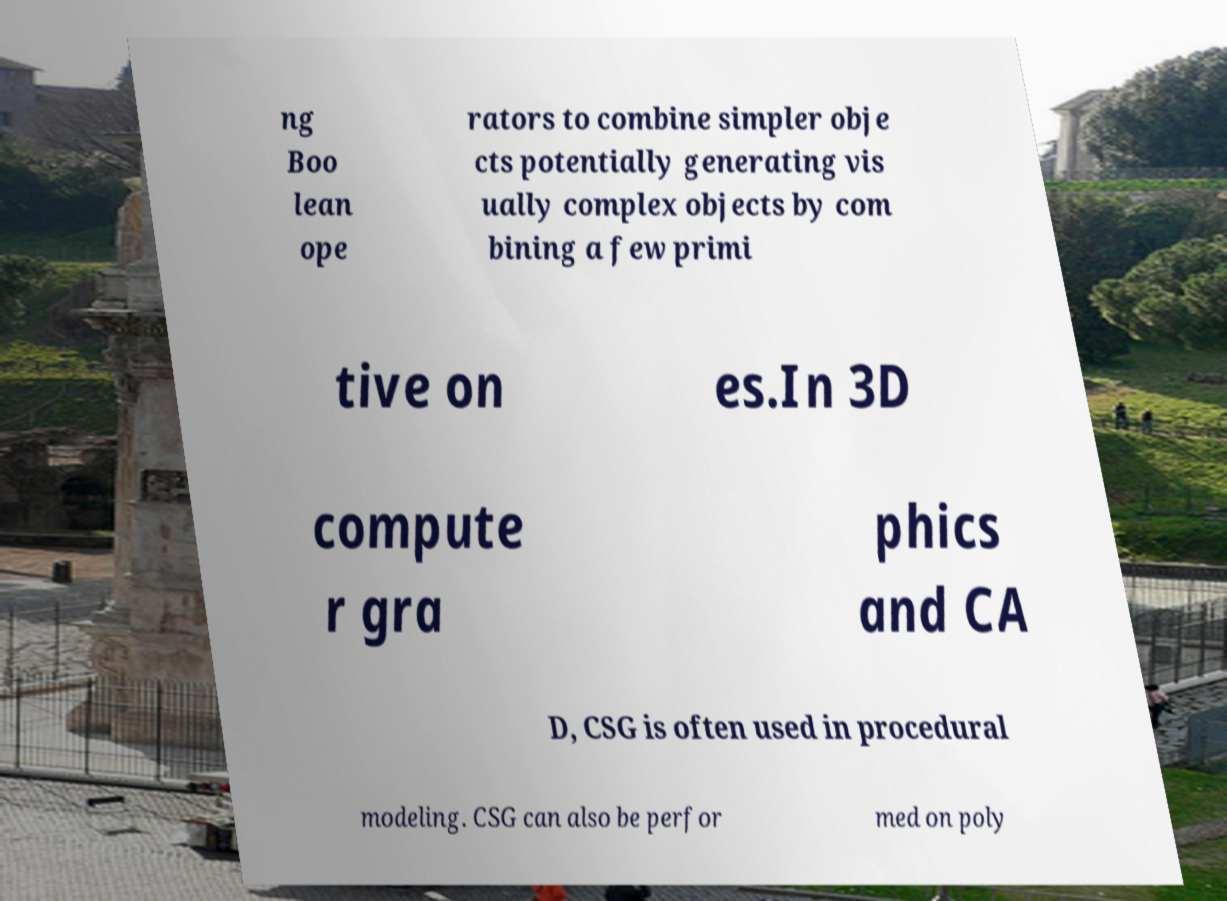Please read and relay the text visible in this image. What does it say? ng Boo lean ope rators to combine simpler obje cts potentially generating vis ually complex objects by com bining a few primi tive on es.In 3D compute r gra phics and CA D, CSG is often used in procedural modeling. CSG can also be perfor med on poly 